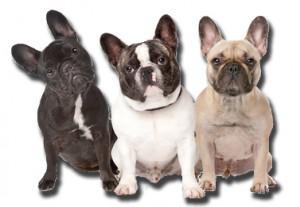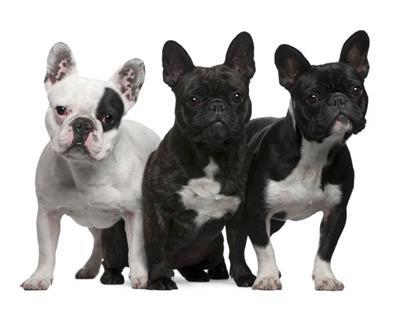The first image is the image on the left, the second image is the image on the right. Examine the images to the left and right. Is the description "The right image contains exactly three dogs." accurate? Answer yes or no. Yes. The first image is the image on the left, the second image is the image on the right. Assess this claim about the two images: "Each image contains the same number of dogs, and all dogs are posed side-by-side.". Correct or not? Answer yes or no. Yes. 